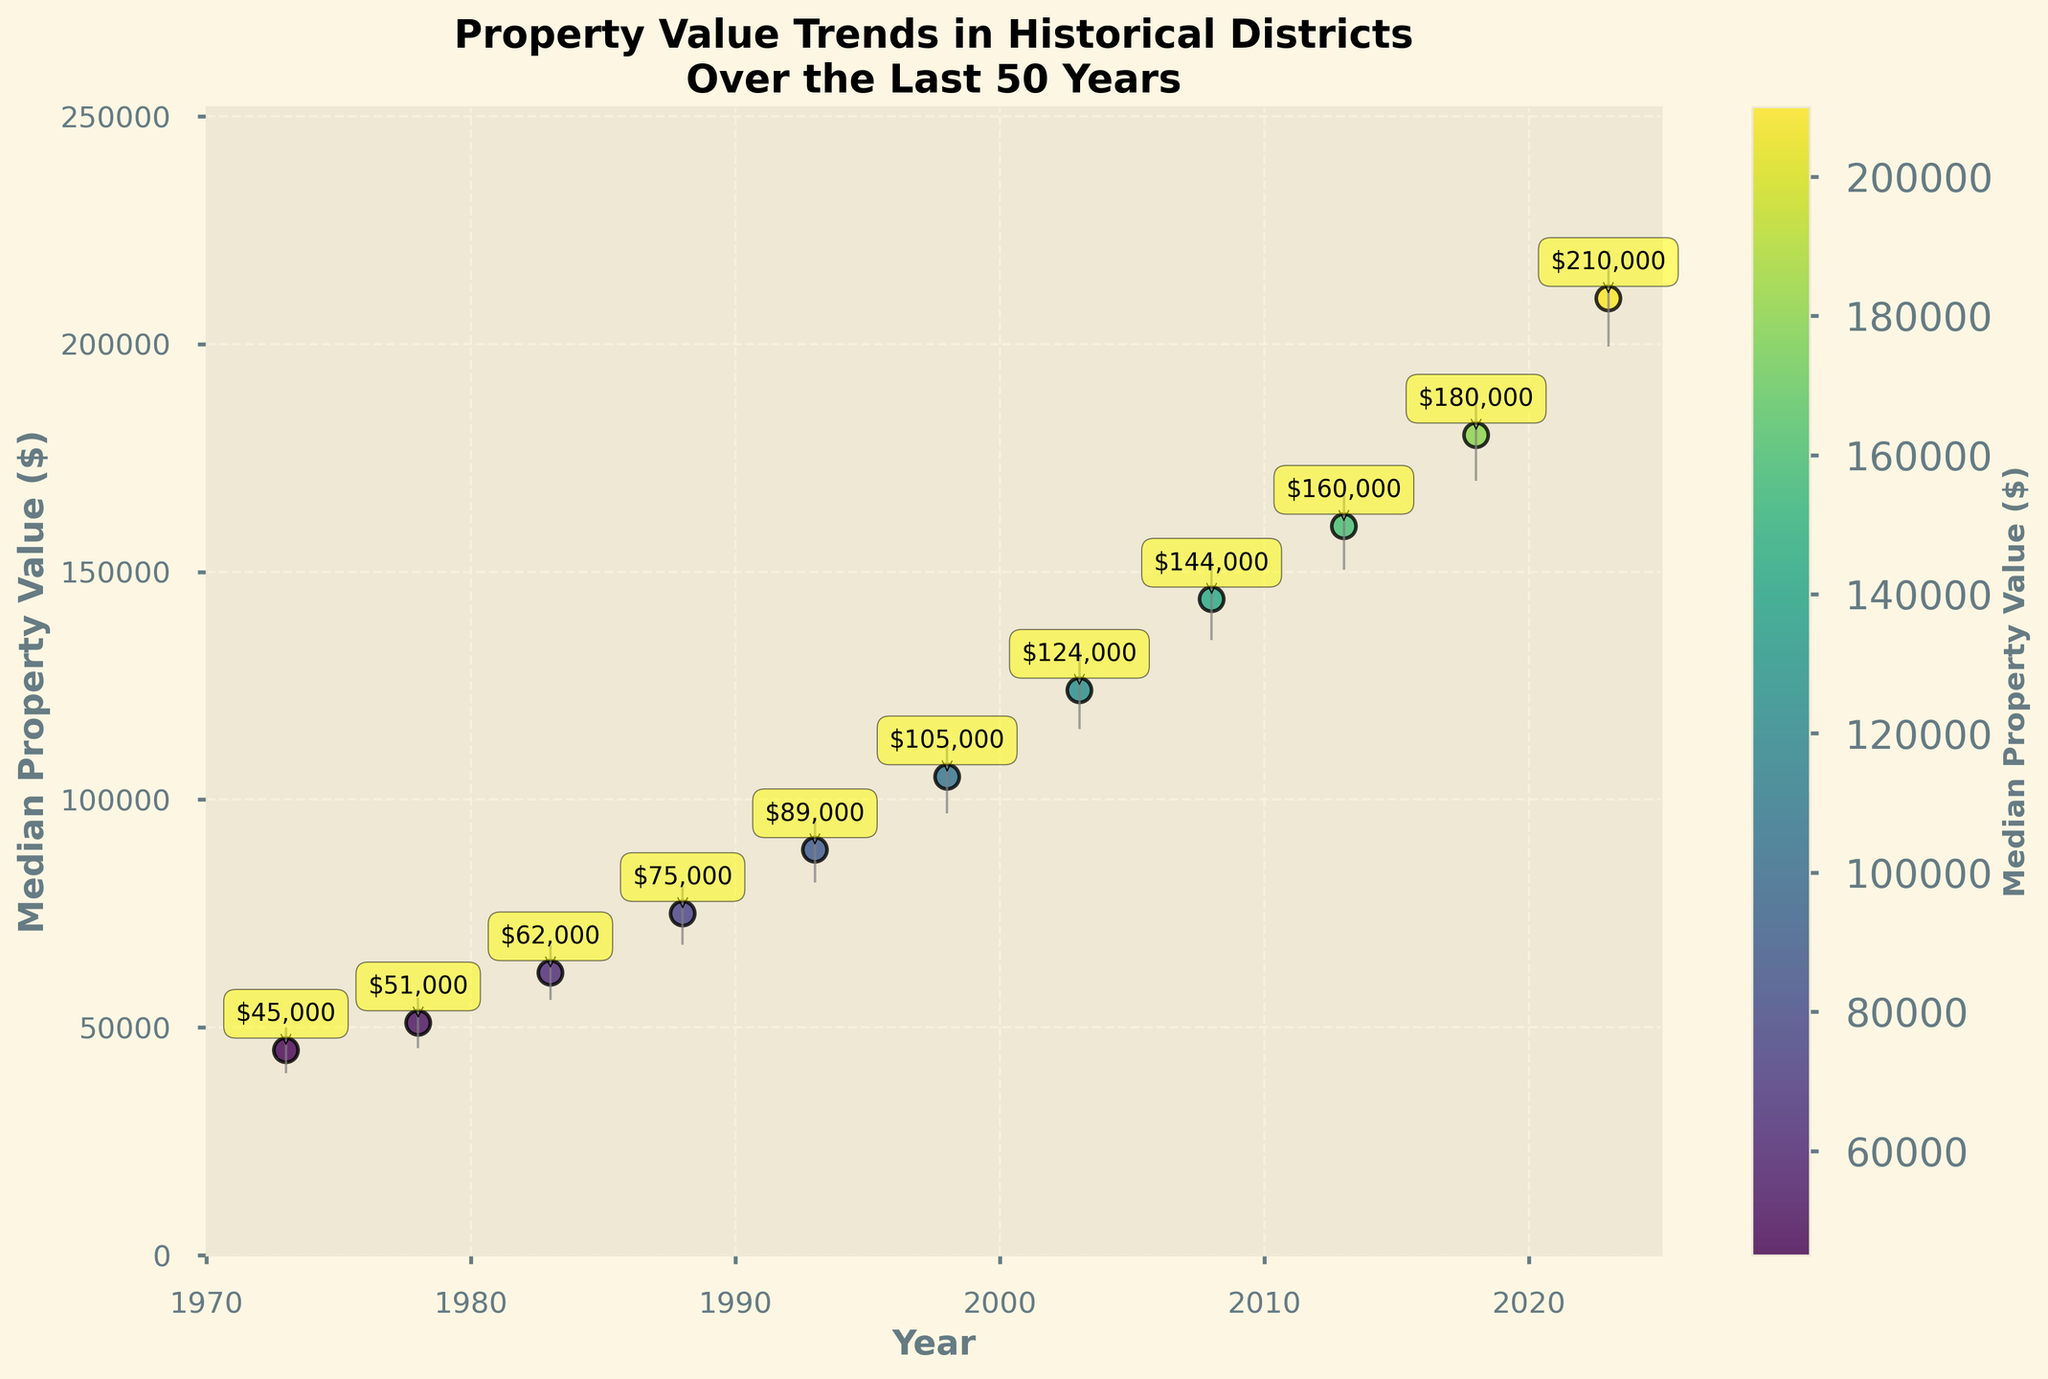What is the title of the plot? The title is located at the top of the plot, and it spans two lines. It reads: "Property Value Trends in Historical Districts\nOver the Last 50 Years."
Answer: Property Value Trends in Historical Districts Over the Last 50 Years What is the median property value in 2023? Locate the data point corresponding to the year 2023 on the x-axis and check the y-value. The annotation near the data point shows the median property value.
Answer: $210,000 Between which years can we see the most significant increase in median property value? Compare the increase between consecutive years by looking at the gap between their corresponding y-values. The largest gap is between 2018 ($180,000) and 2023 ($210,000), a difference of $30,000.
Answer: 2018 and 2023 What is the range of property values in 1998 given the error bars? The median property value in 1998 is $105,000, with a standard deviation of $8,000. Adding and subtracting this from the median gives the range [$97,000, $113,000].
Answer: $97,000 to $113,000 How many data points are on the plot? Count the number of distinct points along the x-axis, each corresponding to a year, and there are 11 such points (from 1973 to 2023).
Answer: 11 Which year has the smallest standard deviation, and what is its value? Compare the error bars' lengths. The shortest error bar belongs to 1973, and the standard deviation is indicated as $5,000.
Answer: 1973, $5,000 What is the total increase in median property value from 1973 to 2023? Subtract the median property value in 1973 ($45,000) from the value in 2023 ($210,000). The increase is $210,000 - $45,000 = $165,000.
Answer: $165,000 How has the standard deviation of property values changed from 1973 to 2023? Compare the length of the error bars from 1973 ($5,000) to 2023 ($10,500). The standard deviation has increased by $5,500.
Answer: Increased by $5,500 Which year has the median property value closest to $100,000? Locate the data points and their annotations. The property value in 1998 is $105,000, which is the closest to $100,000.
Answer: 1998 